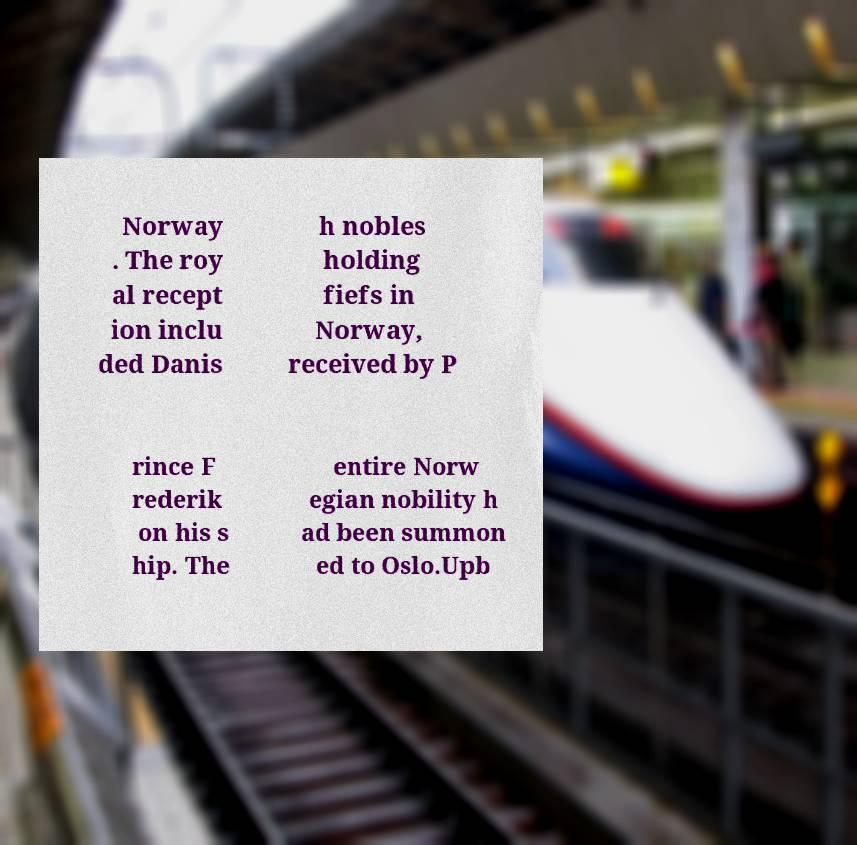Please identify and transcribe the text found in this image. Norway . The roy al recept ion inclu ded Danis h nobles holding fiefs in Norway, received by P rince F rederik on his s hip. The entire Norw egian nobility h ad been summon ed to Oslo.Upb 